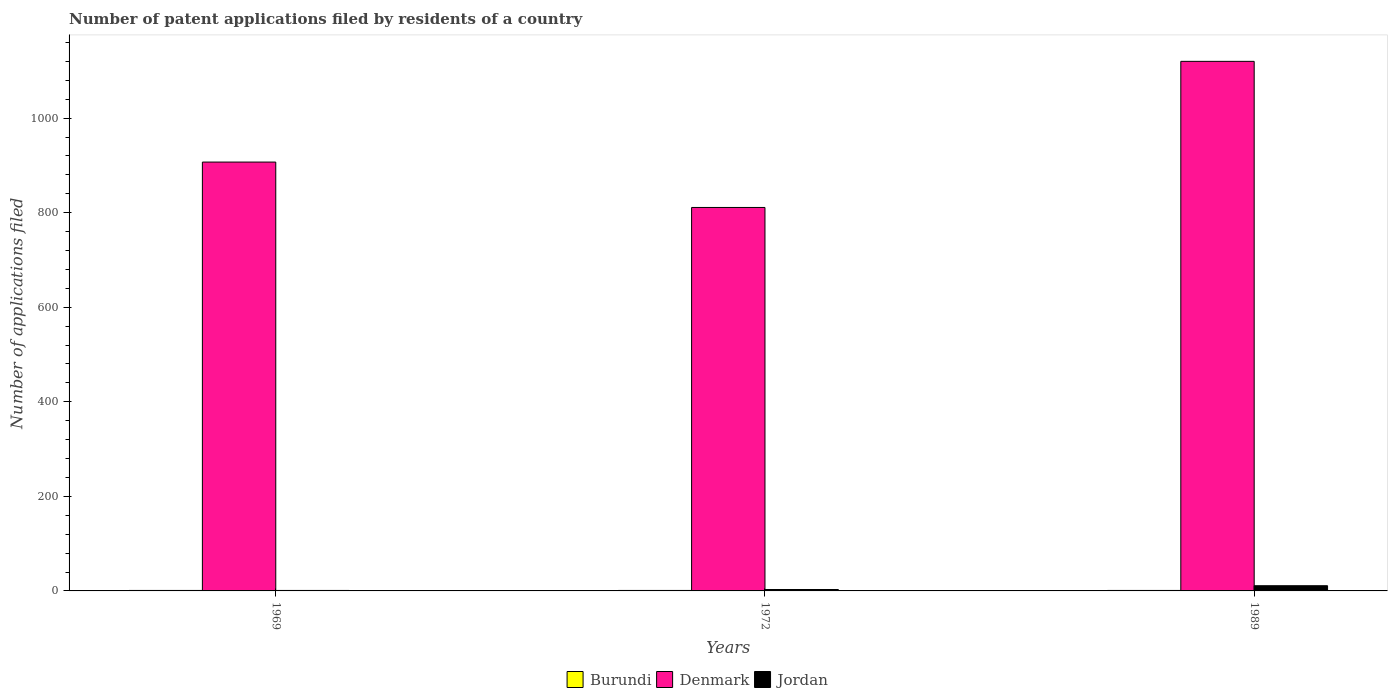How many bars are there on the 3rd tick from the right?
Your response must be concise. 3. What is the label of the 3rd group of bars from the left?
Your answer should be compact. 1989. In how many cases, is the number of bars for a given year not equal to the number of legend labels?
Your response must be concise. 0. Across all years, what is the maximum number of applications filed in Jordan?
Keep it short and to the point. 11. In which year was the number of applications filed in Jordan maximum?
Your answer should be compact. 1989. In which year was the number of applications filed in Jordan minimum?
Give a very brief answer. 1969. What is the total number of applications filed in Burundi in the graph?
Provide a short and direct response. 3. What is the difference between the number of applications filed in Jordan in 1969 and that in 1972?
Keep it short and to the point. -2. What is the difference between the number of applications filed in Denmark in 1969 and the number of applications filed in Jordan in 1972?
Provide a succinct answer. 904. What is the average number of applications filed in Denmark per year?
Your answer should be very brief. 946. In the year 1989, what is the difference between the number of applications filed in Denmark and number of applications filed in Jordan?
Make the answer very short. 1109. What is the ratio of the number of applications filed in Burundi in 1972 to that in 1989?
Ensure brevity in your answer.  1. Is the number of applications filed in Burundi in 1969 less than that in 1989?
Your answer should be compact. No. Is the difference between the number of applications filed in Denmark in 1969 and 1989 greater than the difference between the number of applications filed in Jordan in 1969 and 1989?
Give a very brief answer. No. What is the difference between the highest and the second highest number of applications filed in Denmark?
Offer a very short reply. 213. What is the difference between the highest and the lowest number of applications filed in Burundi?
Keep it short and to the point. 0. In how many years, is the number of applications filed in Denmark greater than the average number of applications filed in Denmark taken over all years?
Make the answer very short. 1. What does the 3rd bar from the left in 1969 represents?
Keep it short and to the point. Jordan. What does the 1st bar from the right in 1969 represents?
Offer a terse response. Jordan. Is it the case that in every year, the sum of the number of applications filed in Jordan and number of applications filed in Denmark is greater than the number of applications filed in Burundi?
Offer a terse response. Yes. How many bars are there?
Keep it short and to the point. 9. Are all the bars in the graph horizontal?
Give a very brief answer. No. What is the difference between two consecutive major ticks on the Y-axis?
Offer a very short reply. 200. How many legend labels are there?
Your response must be concise. 3. How are the legend labels stacked?
Offer a very short reply. Horizontal. What is the title of the graph?
Give a very brief answer. Number of patent applications filed by residents of a country. What is the label or title of the Y-axis?
Keep it short and to the point. Number of applications filed. What is the Number of applications filed in Denmark in 1969?
Keep it short and to the point. 907. What is the Number of applications filed of Jordan in 1969?
Give a very brief answer. 1. What is the Number of applications filed of Denmark in 1972?
Your answer should be very brief. 811. What is the Number of applications filed of Jordan in 1972?
Your answer should be compact. 3. What is the Number of applications filed in Burundi in 1989?
Make the answer very short. 1. What is the Number of applications filed of Denmark in 1989?
Your response must be concise. 1120. Across all years, what is the maximum Number of applications filed in Denmark?
Provide a short and direct response. 1120. Across all years, what is the minimum Number of applications filed of Burundi?
Provide a succinct answer. 1. Across all years, what is the minimum Number of applications filed in Denmark?
Give a very brief answer. 811. What is the total Number of applications filed of Burundi in the graph?
Provide a succinct answer. 3. What is the total Number of applications filed in Denmark in the graph?
Your answer should be compact. 2838. What is the total Number of applications filed of Jordan in the graph?
Keep it short and to the point. 15. What is the difference between the Number of applications filed of Burundi in 1969 and that in 1972?
Offer a very short reply. 0. What is the difference between the Number of applications filed of Denmark in 1969 and that in 1972?
Offer a very short reply. 96. What is the difference between the Number of applications filed of Burundi in 1969 and that in 1989?
Provide a succinct answer. 0. What is the difference between the Number of applications filed in Denmark in 1969 and that in 1989?
Give a very brief answer. -213. What is the difference between the Number of applications filed of Burundi in 1972 and that in 1989?
Make the answer very short. 0. What is the difference between the Number of applications filed in Denmark in 1972 and that in 1989?
Ensure brevity in your answer.  -309. What is the difference between the Number of applications filed in Jordan in 1972 and that in 1989?
Offer a terse response. -8. What is the difference between the Number of applications filed of Burundi in 1969 and the Number of applications filed of Denmark in 1972?
Your response must be concise. -810. What is the difference between the Number of applications filed in Burundi in 1969 and the Number of applications filed in Jordan in 1972?
Your answer should be compact. -2. What is the difference between the Number of applications filed in Denmark in 1969 and the Number of applications filed in Jordan in 1972?
Make the answer very short. 904. What is the difference between the Number of applications filed in Burundi in 1969 and the Number of applications filed in Denmark in 1989?
Give a very brief answer. -1119. What is the difference between the Number of applications filed in Burundi in 1969 and the Number of applications filed in Jordan in 1989?
Keep it short and to the point. -10. What is the difference between the Number of applications filed of Denmark in 1969 and the Number of applications filed of Jordan in 1989?
Keep it short and to the point. 896. What is the difference between the Number of applications filed in Burundi in 1972 and the Number of applications filed in Denmark in 1989?
Your response must be concise. -1119. What is the difference between the Number of applications filed in Burundi in 1972 and the Number of applications filed in Jordan in 1989?
Provide a short and direct response. -10. What is the difference between the Number of applications filed in Denmark in 1972 and the Number of applications filed in Jordan in 1989?
Provide a short and direct response. 800. What is the average Number of applications filed of Burundi per year?
Offer a very short reply. 1. What is the average Number of applications filed of Denmark per year?
Your response must be concise. 946. In the year 1969, what is the difference between the Number of applications filed of Burundi and Number of applications filed of Denmark?
Give a very brief answer. -906. In the year 1969, what is the difference between the Number of applications filed of Burundi and Number of applications filed of Jordan?
Offer a very short reply. 0. In the year 1969, what is the difference between the Number of applications filed of Denmark and Number of applications filed of Jordan?
Your answer should be compact. 906. In the year 1972, what is the difference between the Number of applications filed in Burundi and Number of applications filed in Denmark?
Give a very brief answer. -810. In the year 1972, what is the difference between the Number of applications filed in Denmark and Number of applications filed in Jordan?
Offer a terse response. 808. In the year 1989, what is the difference between the Number of applications filed of Burundi and Number of applications filed of Denmark?
Keep it short and to the point. -1119. In the year 1989, what is the difference between the Number of applications filed of Burundi and Number of applications filed of Jordan?
Your answer should be very brief. -10. In the year 1989, what is the difference between the Number of applications filed of Denmark and Number of applications filed of Jordan?
Your answer should be compact. 1109. What is the ratio of the Number of applications filed of Denmark in 1969 to that in 1972?
Provide a succinct answer. 1.12. What is the ratio of the Number of applications filed of Jordan in 1969 to that in 1972?
Ensure brevity in your answer.  0.33. What is the ratio of the Number of applications filed in Burundi in 1969 to that in 1989?
Make the answer very short. 1. What is the ratio of the Number of applications filed in Denmark in 1969 to that in 1989?
Provide a succinct answer. 0.81. What is the ratio of the Number of applications filed in Jordan in 1969 to that in 1989?
Offer a terse response. 0.09. What is the ratio of the Number of applications filed of Denmark in 1972 to that in 1989?
Give a very brief answer. 0.72. What is the ratio of the Number of applications filed of Jordan in 1972 to that in 1989?
Ensure brevity in your answer.  0.27. What is the difference between the highest and the second highest Number of applications filed of Denmark?
Offer a terse response. 213. What is the difference between the highest and the second highest Number of applications filed of Jordan?
Provide a succinct answer. 8. What is the difference between the highest and the lowest Number of applications filed of Denmark?
Your response must be concise. 309. 